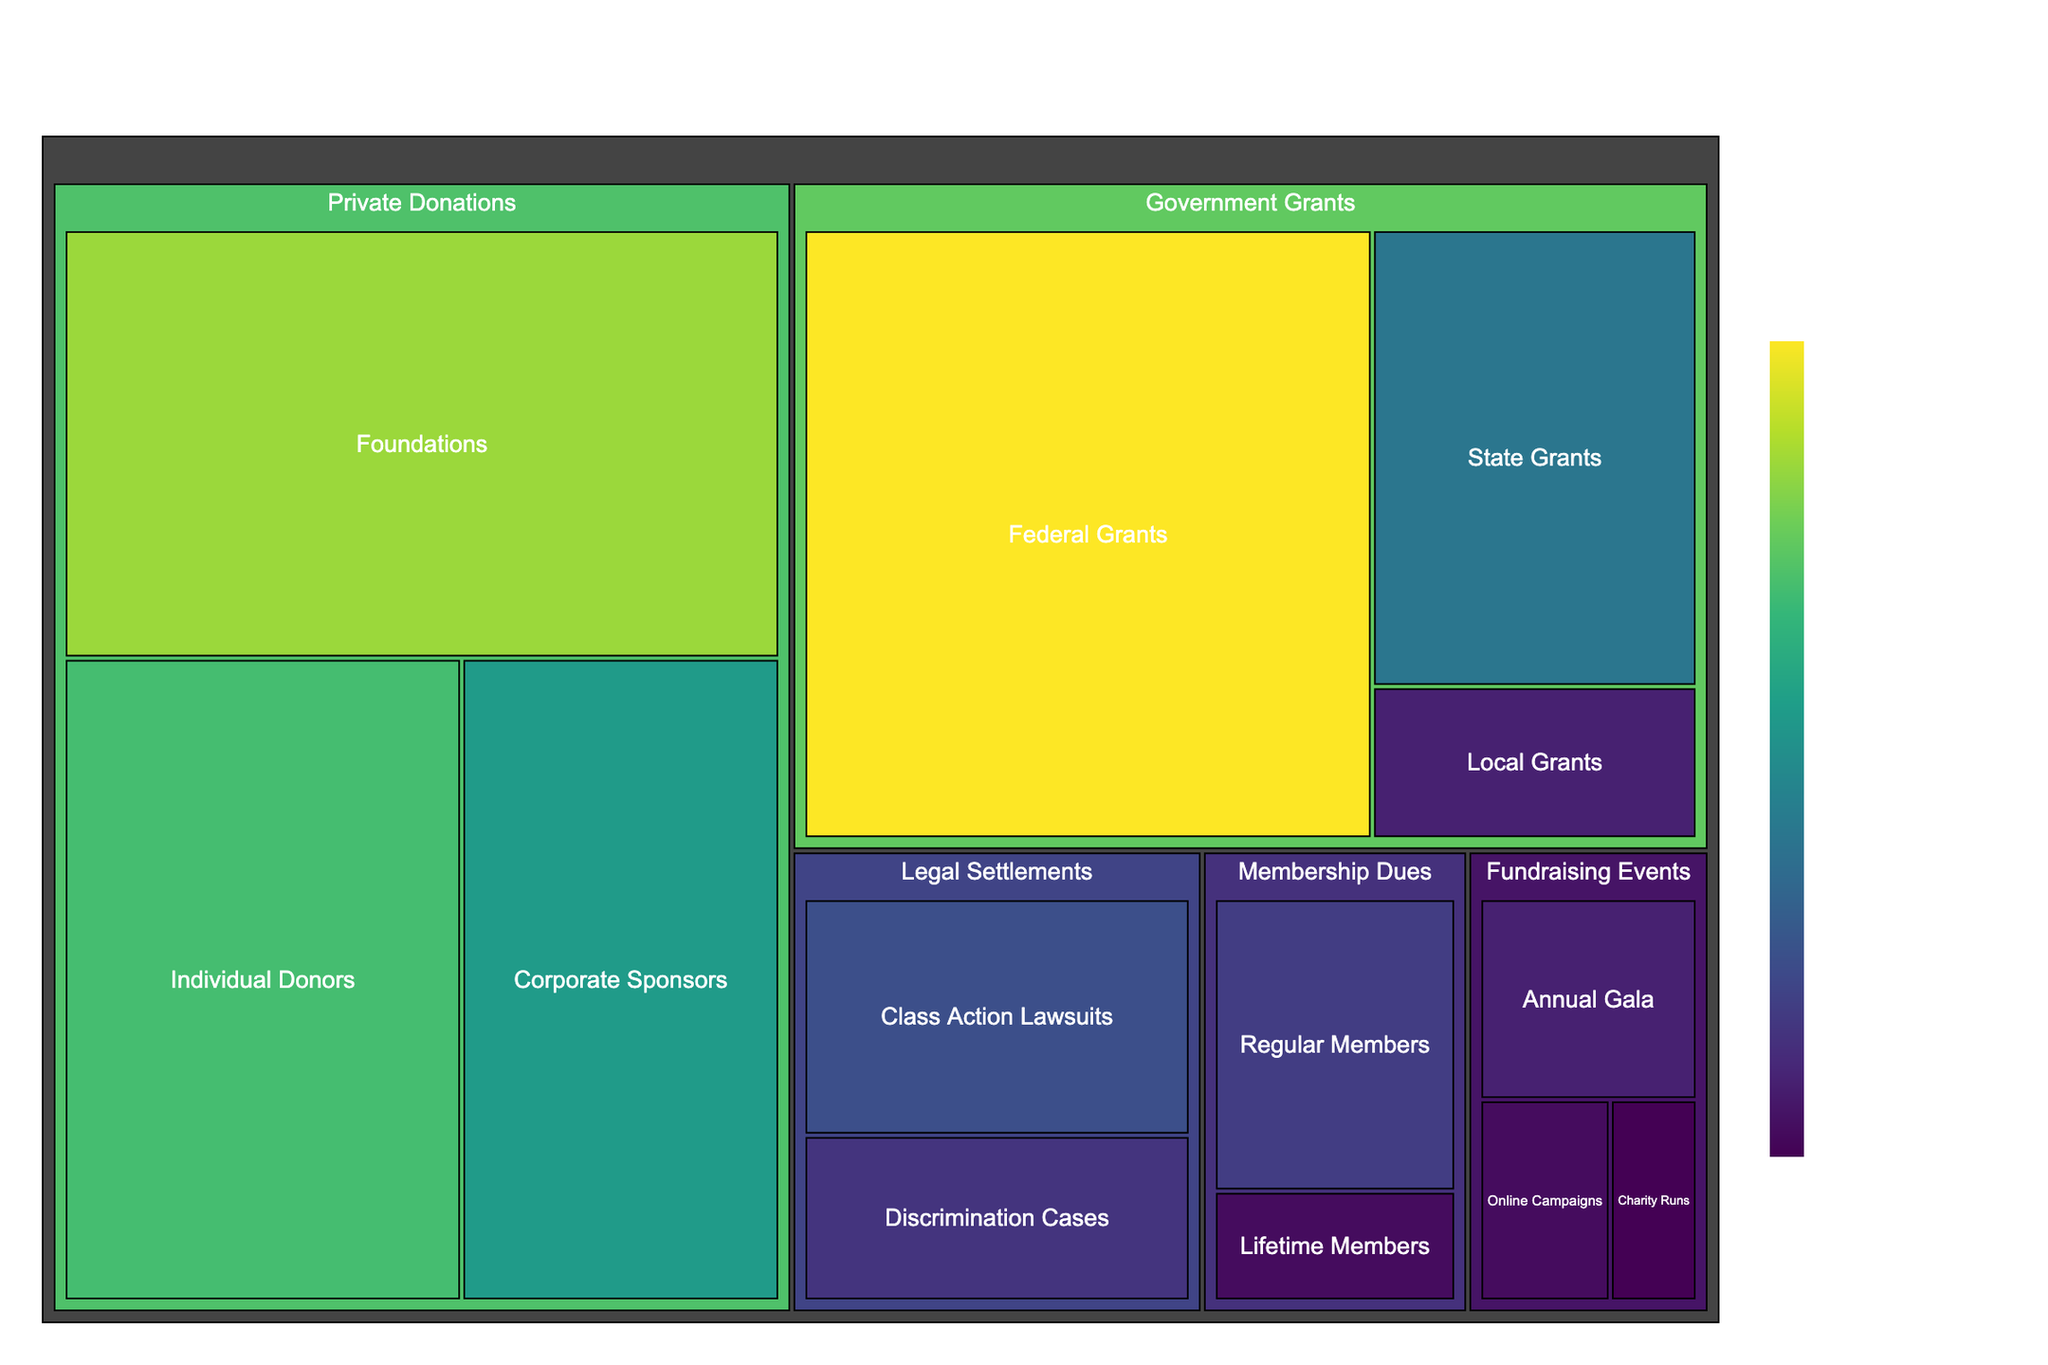What is the title of the treemap? The title of the treemap can typically be found at the top or near the top of the figure, providing a concise description of the content.
Answer: Breakdown of Funding Sources for Civil Rights Organizations Which subcategory has the highest funding amount? To find this, look for the largest segment within the treemap and identify its label. The hover tooltip also provides detailed information. In this case, "Federal Grants" is the largest segment.
Answer: Federal Grants What is the total funding from Government Grants? The categories under Government Grants are "Federal Grants," "State Grants," and "Local Grants." Summing these amounts: $35,000,000 + $15,000,000 + $5,000,000 = $55,000,000.
Answer: $55,000,000 How does the funding from Individual Donors compare to Corporate Sponsors? Look for the sizes of the segments associated with "Individual Donors" and "Corporate Sponsors." "Individual Donors" amount to $25,000,000 while "Corporate Sponsors" amount to $20,000,000. As a result, Individual Donors contribute more.
Answer: Individual Donors contribute more Which category contributes the least to the funding? The size of each category segment indicates its total amount. By comparing the visible sizes, "Membership Dues" (totaling $8,000,000 + $3,000,000 = $11,000,000) contributes the least.
Answer: Membership Dues What is the total amount generated from Fundraising Events? Add up the values from the subcategories within "Fundraising Events": $5,000,000 (Annual Gala) + $2,000,000 (Charity Runs) + $3,000,000 (Online Campaigns). The total is $10,000,000.
Answer: $10,000,000 Which subcategory under Legal Settlements has a higher contribution? Compare the sizes of "Class Action Lawsuits" and "Discrimination Cases." "Class Action Lawsuits" contribute $10,000,000, whereas "Discrimination Cases" contribute $7,000,000.
Answer: Class Action Lawsuits How much more funding do Foundations provide compared to Lifetime Members? Found "Foundations" and "Lifetime Members" subcategories on the treemap. Subtract the value for Lifetime Members ($3,000,000) from Foundations ($30,000,000). The difference is $27,000,000.
Answer: $27,000,000 What proportion of the total funding comes from Private Donations? Calculate the total funding from all sources and then the total for Private Donations. The total funding is $148,000,000 and Private Donations total $75,000,000. The proportion is $75,000,000 / $148,000,000 ≈ 0.507 or 50.7%.
Answer: 50.7% Which funding source contributes more: State Grants or Online Campaigns? Locate the segments for "State Grants" and "Online Campaigns." "State Grants" contribute $15,000,000 while "Online Campaigns" contribute $3,000,000. State Grants contribute more.
Answer: State Grants 